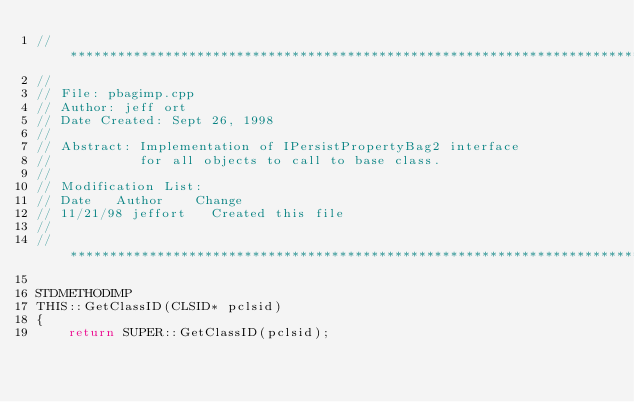<code> <loc_0><loc_0><loc_500><loc_500><_C++_>//*****************************************************************************
//
// File: pbagimp.cpp
// Author: jeff ort
// Date Created: Sept 26, 1998
//
// Abstract: Implementation of IPersistPropertyBag2 interface
//           for all objects to call to base class.
//
// Modification List:
// Date		Author		Change
// 11/21/98	jeffort		Created this file
//
//*****************************************************************************

STDMETHODIMP 
THIS::GetClassID(CLSID* pclsid)
{
    return SUPER::GetClassID(pclsid);</code> 